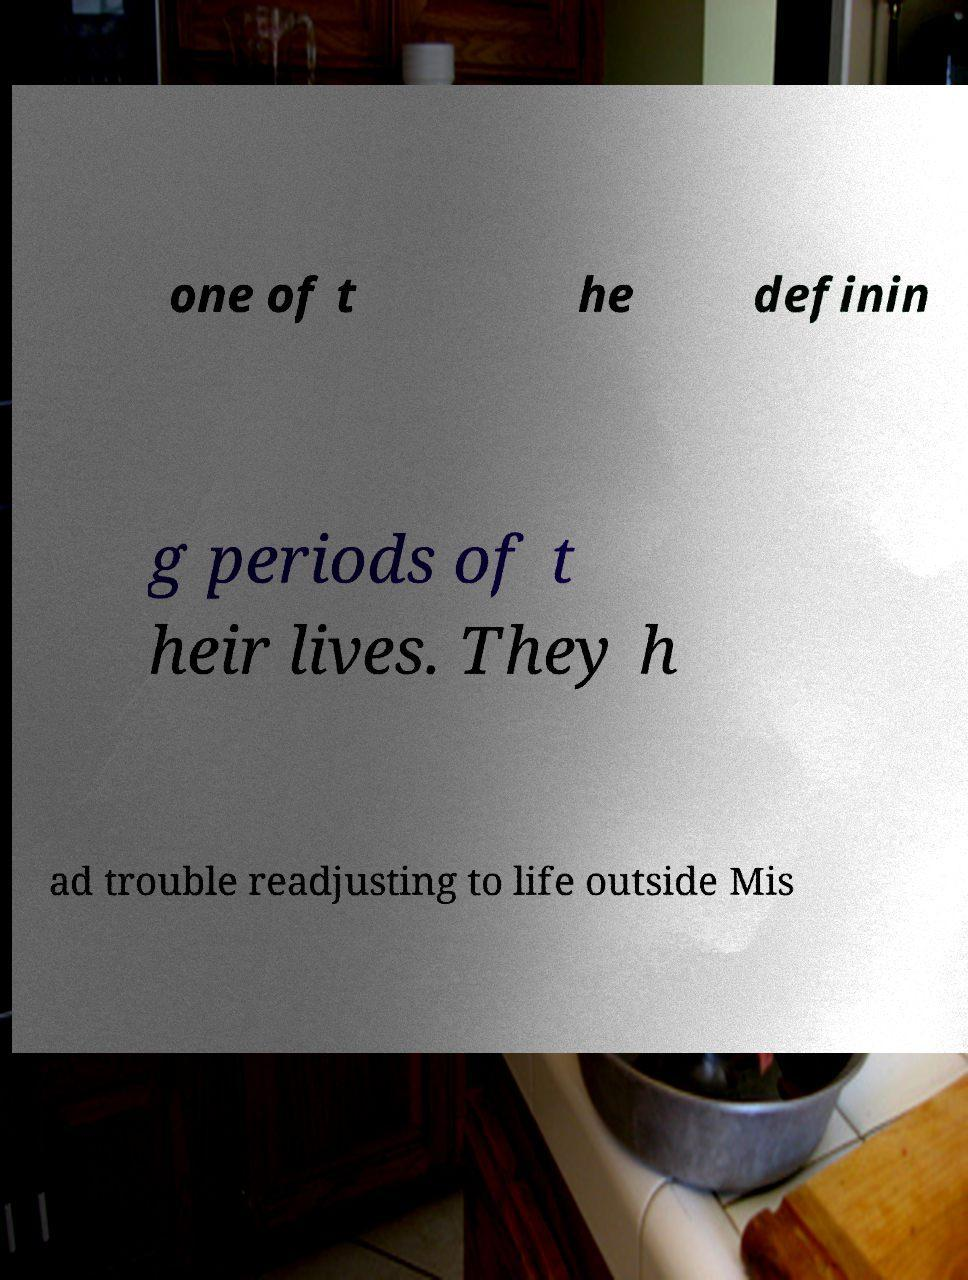Please identify and transcribe the text found in this image. one of t he definin g periods of t heir lives. They h ad trouble readjusting to life outside Mis 